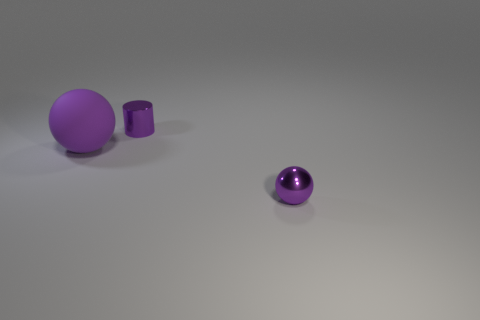Are there any other small cylinders of the same color as the small shiny cylinder? no 